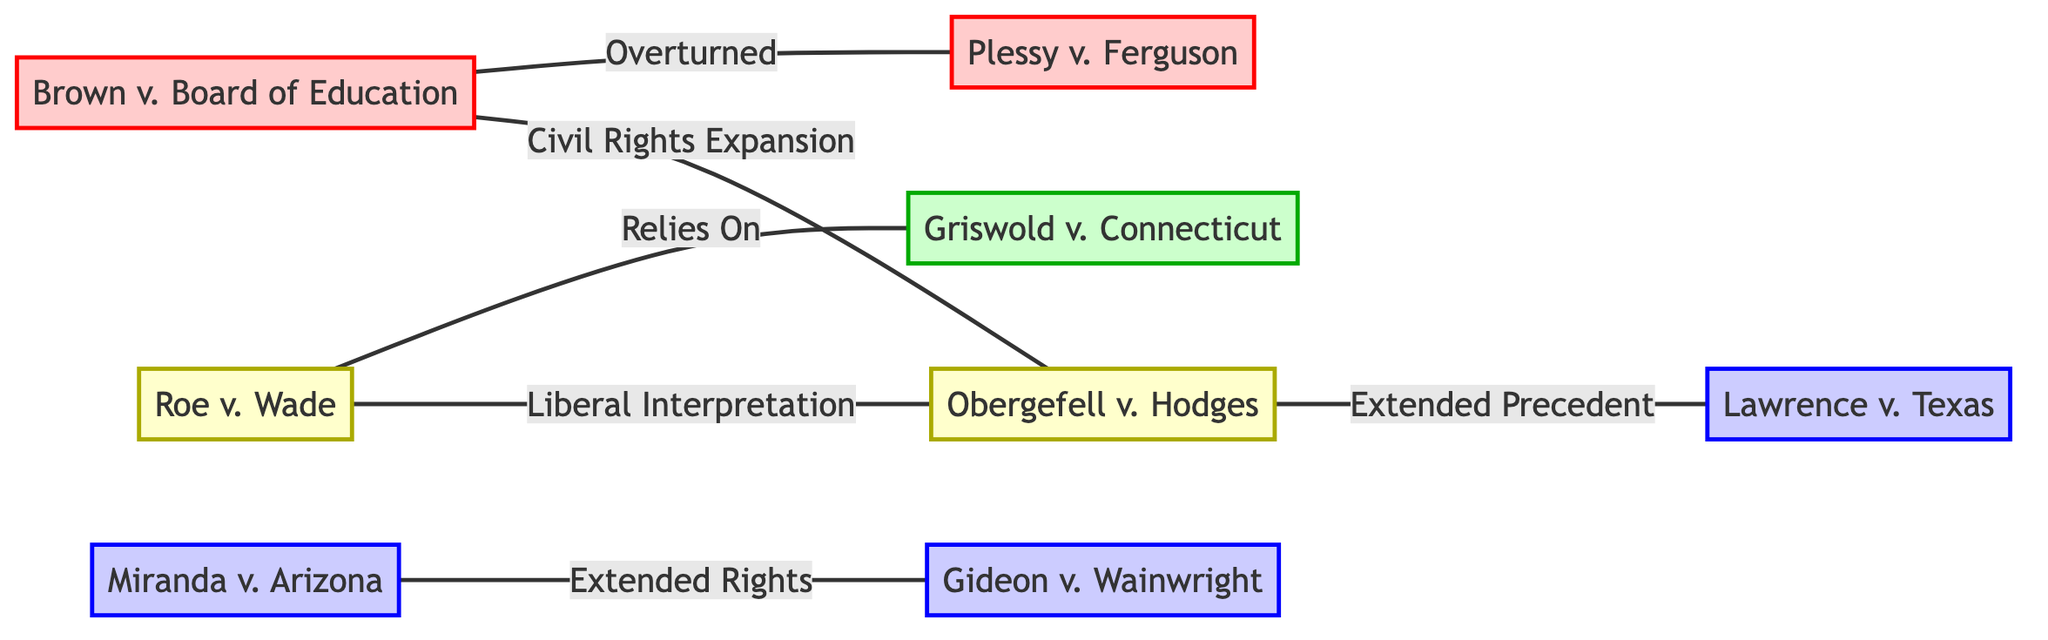What precedent did Brown v. Board of Education overturn? The diagram indicates a direct connection between Brown v. Board of Education and Plessy v. Ferguson with the relationship labeled "Overturned." Thus, according to the visual information presented, Plessy v. Ferguson is the precedent that Brown v. Board of Education overturned.
Answer: Plessy v. Ferguson Which case relies on Griswold v. Connecticut? From the visual representation, there is an edge from Roe v. Wade to Griswold v. Connecticut with the relationship labeled "Relies On." Therefore, Roe v. Wade is the case that relies on Griswold v. Connecticut.
Answer: Roe v. Wade How many total nodes are present in the graph? The graph lists eight distinct landmark cases as nodes: Brown v. Board of Education, Plessy v. Ferguson, Roe v. Wade, Griswold v. Connecticut, Miranda v. Arizona, Gideon v. Wainwright, Obergefell v. Hodges, and Lawrence v. Texas. Counting these nodes gives a total of eight.
Answer: 8 Which cases are connected to Obergefell v. Hodges, and how? The graph shows that Obergefell v. Hodges is connected to Lawrence v. Texas (relationship labeled "Extended Precedent") and to Roe v. Wade (relationship labeled "Liberal Interpretation") as well as to Brown v. Board of Education (relationship labeled "Civil Rights Expansion"). Thus, the direct links to Obergefell v. Hodges indicate that it is connected to Lawrence v. Texas, Roe v. Wade, and Brown v. Board of Education through these specific types of relationships.
Answer: Lawrence v. Texas, Roe v. Wade, Brown v. Board of Education What type of relationship does Miranda v. Arizona have with Gideon v. Wainwright? The edge between Miranda v. Arizona and Gideon v. Wainwright in the diagram is labeled "Extended Rights," indicating that the relationship between these two cases is one of extension in rights as established through precedent.
Answer: Extended Rights How many relationships are labeled as "Liberal Interpretation"? The diagram shows a single direct connection with the label "Liberal Interpretation" that goes from Roe v. Wade to Obergefell v. Hodges. Hence, there is only one relationship identified with this specific label in the graph.
Answer: 1 Which relationship extends the rights established by Gideon v. Wainwright? The relationship presented in the graph that extends from Miranda v. Arizona to Gideon v. Wainwright is labeled "Extended Rights." This indicates that Miranda v. Arizona's connection to Gideon v. Wainwright pertains to the expansion of rights.
Answer: Extended Rights What relationship does Brown v. Board of Education have with Obergefell v. Hodges? An edge connects Brown v. Board of Education and Obergefell v. Hodges with the label "Civil Rights Expansion." This signifies that the relationship defines a connection where Brown v. Board of Education contributes to the expansion of civil rights, thereby influencing Obergefell v. Hodges.
Answer: Civil Rights Expansion 